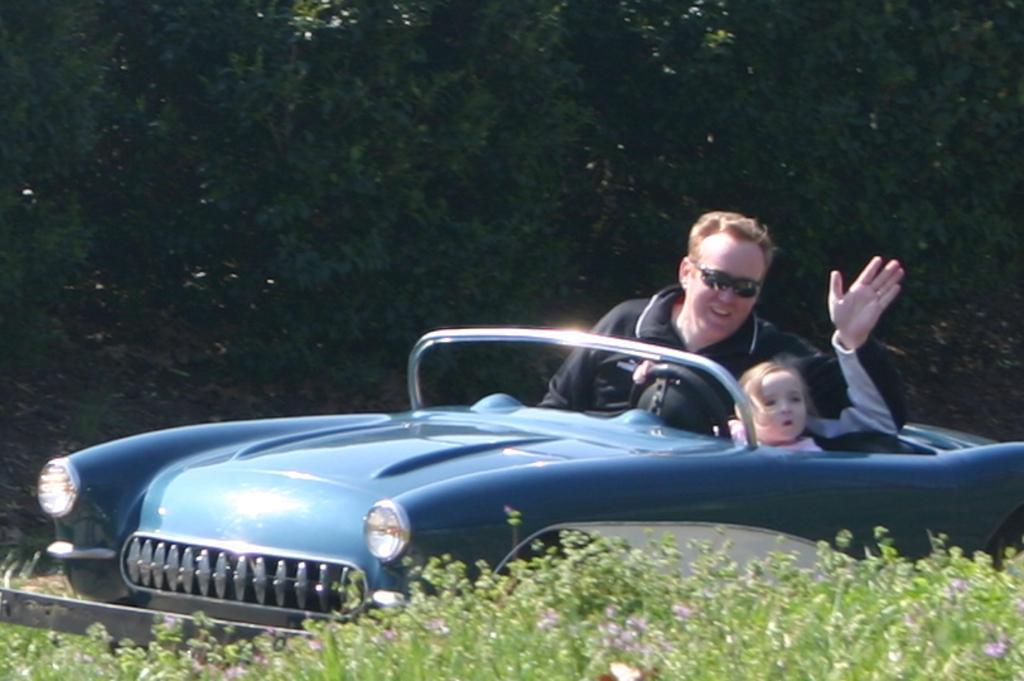Can you describe this image briefly? A man is sitting in a car while a little girl is driving. 